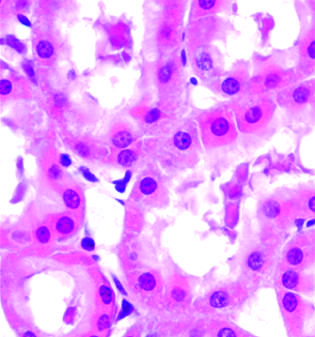what is showing increased eosinophilia of cytoplasm, and swelling of occasional cells?
Answer the question using a single word or phrase. Early (reversible) ischemic injury 